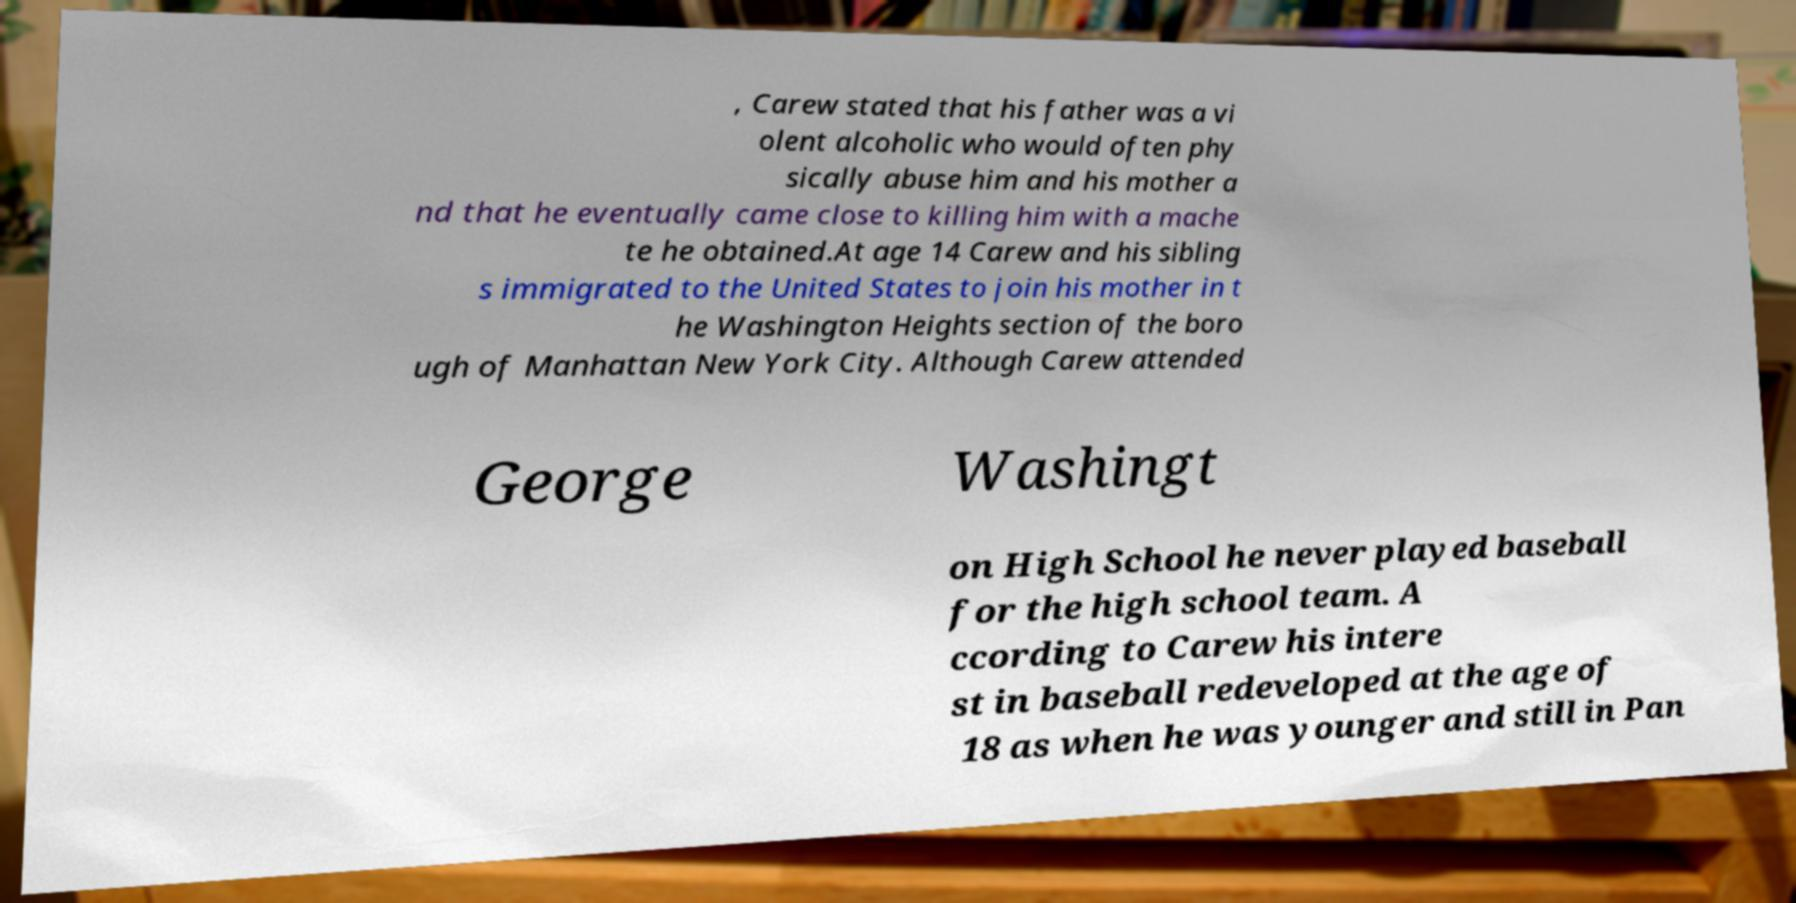Please read and relay the text visible in this image. What does it say? , Carew stated that his father was a vi olent alcoholic who would often phy sically abuse him and his mother a nd that he eventually came close to killing him with a mache te he obtained.At age 14 Carew and his sibling s immigrated to the United States to join his mother in t he Washington Heights section of the boro ugh of Manhattan New York City. Although Carew attended George Washingt on High School he never played baseball for the high school team. A ccording to Carew his intere st in baseball redeveloped at the age of 18 as when he was younger and still in Pan 